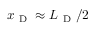Convert formula to latex. <formula><loc_0><loc_0><loc_500><loc_500>x _ { D } \approx L _ { D } / 2</formula> 